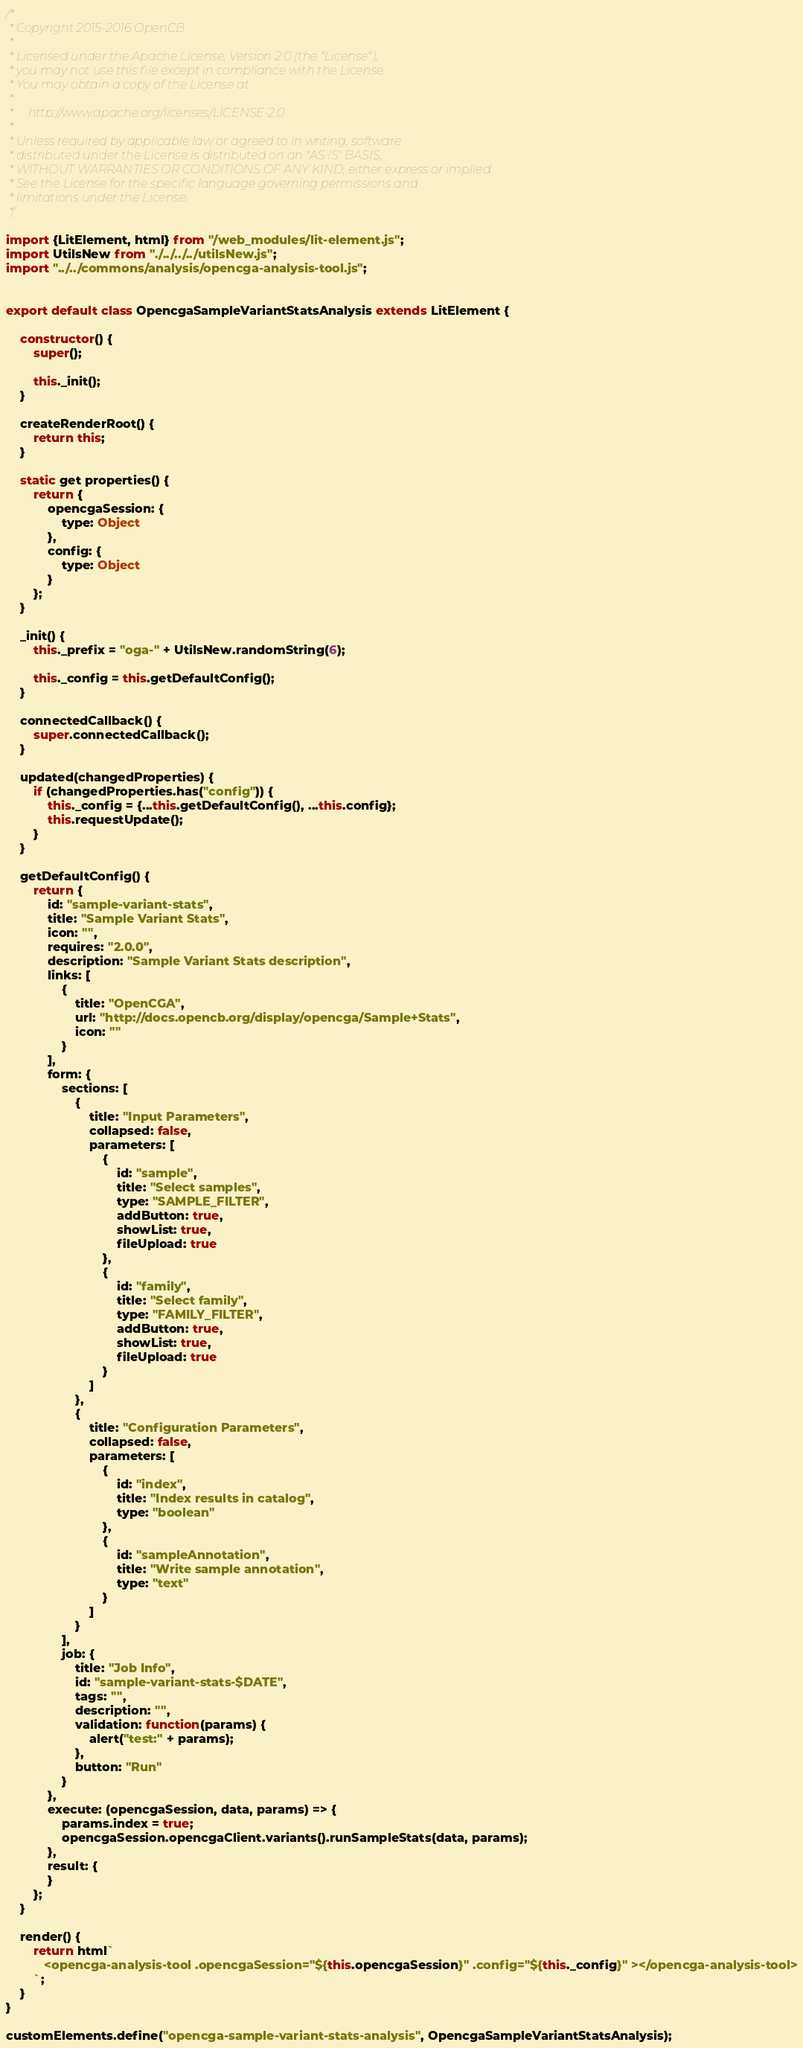Convert code to text. <code><loc_0><loc_0><loc_500><loc_500><_JavaScript_>/*
 * Copyright 2015-2016 OpenCB
 *
 * Licensed under the Apache License, Version 2.0 (the "License");
 * you may not use this file except in compliance with the License.
 * You may obtain a copy of the License at
 *
 *     http://www.apache.org/licenses/LICENSE-2.0
 *
 * Unless required by applicable law or agreed to in writing, software
 * distributed under the License is distributed on an "AS IS" BASIS,
 * WITHOUT WARRANTIES OR CONDITIONS OF ANY KIND, either express or implied.
 * See the License for the specific language governing permissions and
 * limitations under the License.
 */

import {LitElement, html} from "/web_modules/lit-element.js";
import UtilsNew from "./../../../utilsNew.js";
import "../../commons/analysis/opencga-analysis-tool.js";


export default class OpencgaSampleVariantStatsAnalysis extends LitElement {

    constructor() {
        super();

        this._init();
    }

    createRenderRoot() {
        return this;
    }

    static get properties() {
        return {
            opencgaSession: {
                type: Object
            },
            config: {
                type: Object
            }
        };
    }

    _init() {
        this._prefix = "oga-" + UtilsNew.randomString(6);

        this._config = this.getDefaultConfig();
    }

    connectedCallback() {
        super.connectedCallback();
    }

    updated(changedProperties) {
        if (changedProperties.has("config")) {
            this._config = {...this.getDefaultConfig(), ...this.config};
            this.requestUpdate();
        }
    }

    getDefaultConfig() {
        return {
            id: "sample-variant-stats",
            title: "Sample Variant Stats",
            icon: "",
            requires: "2.0.0",
            description: "Sample Variant Stats description",
            links: [
                {
                    title: "OpenCGA",
                    url: "http://docs.opencb.org/display/opencga/Sample+Stats",
                    icon: ""
                }
            ],
            form: {
                sections: [
                    {
                        title: "Input Parameters",
                        collapsed: false,
                        parameters: [
                            {
                                id: "sample",
                                title: "Select samples",
                                type: "SAMPLE_FILTER",
                                addButton: true,
                                showList: true,
                                fileUpload: true
                            },
                            {
                                id: "family",
                                title: "Select family",
                                type: "FAMILY_FILTER",
                                addButton: true,
                                showList: true,
                                fileUpload: true
                            }
                        ]
                    },
                    {
                        title: "Configuration Parameters",
                        collapsed: false,
                        parameters: [
                            {
                                id: "index",
                                title: "Index results in catalog",
                                type: "boolean"
                            },
                            {
                                id: "sampleAnnotation",
                                title: "Write sample annotation",
                                type: "text"
                            }
                        ]
                    }
                ],
                job: {
                    title: "Job Info",
                    id: "sample-variant-stats-$DATE",
                    tags: "",
                    description: "",
                    validation: function(params) {
                        alert("test:" + params);
                    },
                    button: "Run"
                }
            },
            execute: (opencgaSession, data, params) => {
                params.index = true;
                opencgaSession.opencgaClient.variants().runSampleStats(data, params);
            },
            result: {
            }
        };
    }

    render() {
        return html`
           <opencga-analysis-tool .opencgaSession="${this.opencgaSession}" .config="${this._config}" ></opencga-analysis-tool>
        `;
    }
}

customElements.define("opencga-sample-variant-stats-analysis", OpencgaSampleVariantStatsAnalysis);
</code> 